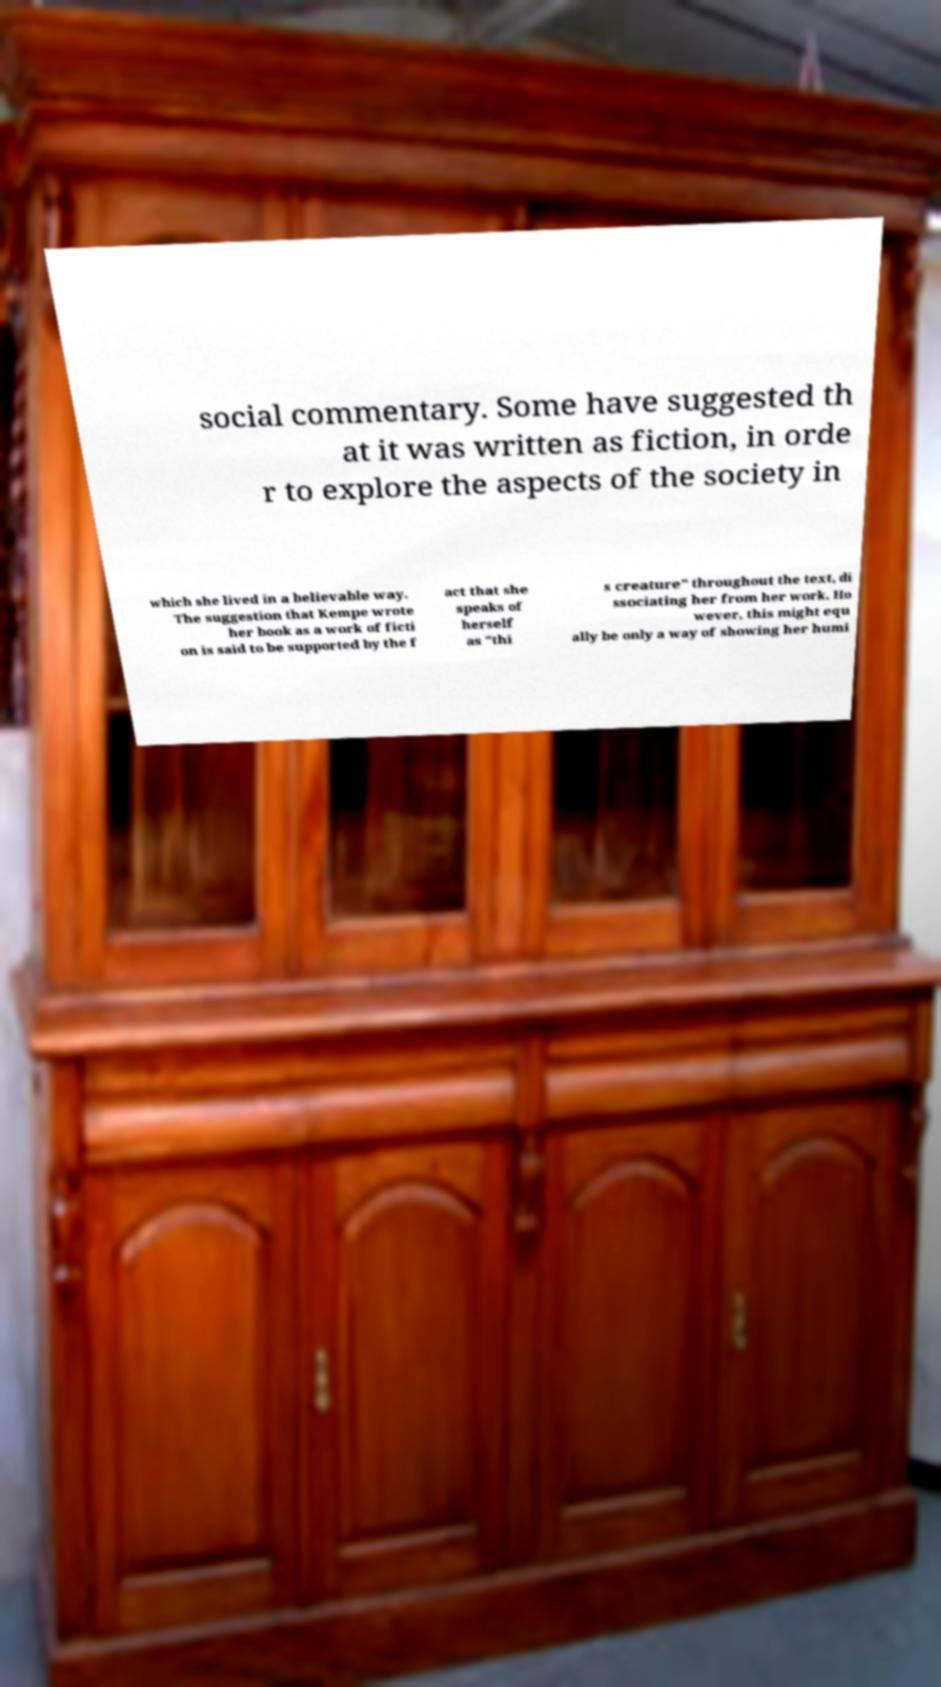Could you assist in decoding the text presented in this image and type it out clearly? social commentary. Some have suggested th at it was written as fiction, in orde r to explore the aspects of the society in which she lived in a believable way. The suggestion that Kempe wrote her book as a work of ficti on is said to be supported by the f act that she speaks of herself as "thi s creature" throughout the text, di ssociating her from her work. Ho wever, this might equ ally be only a way of showing her humi 